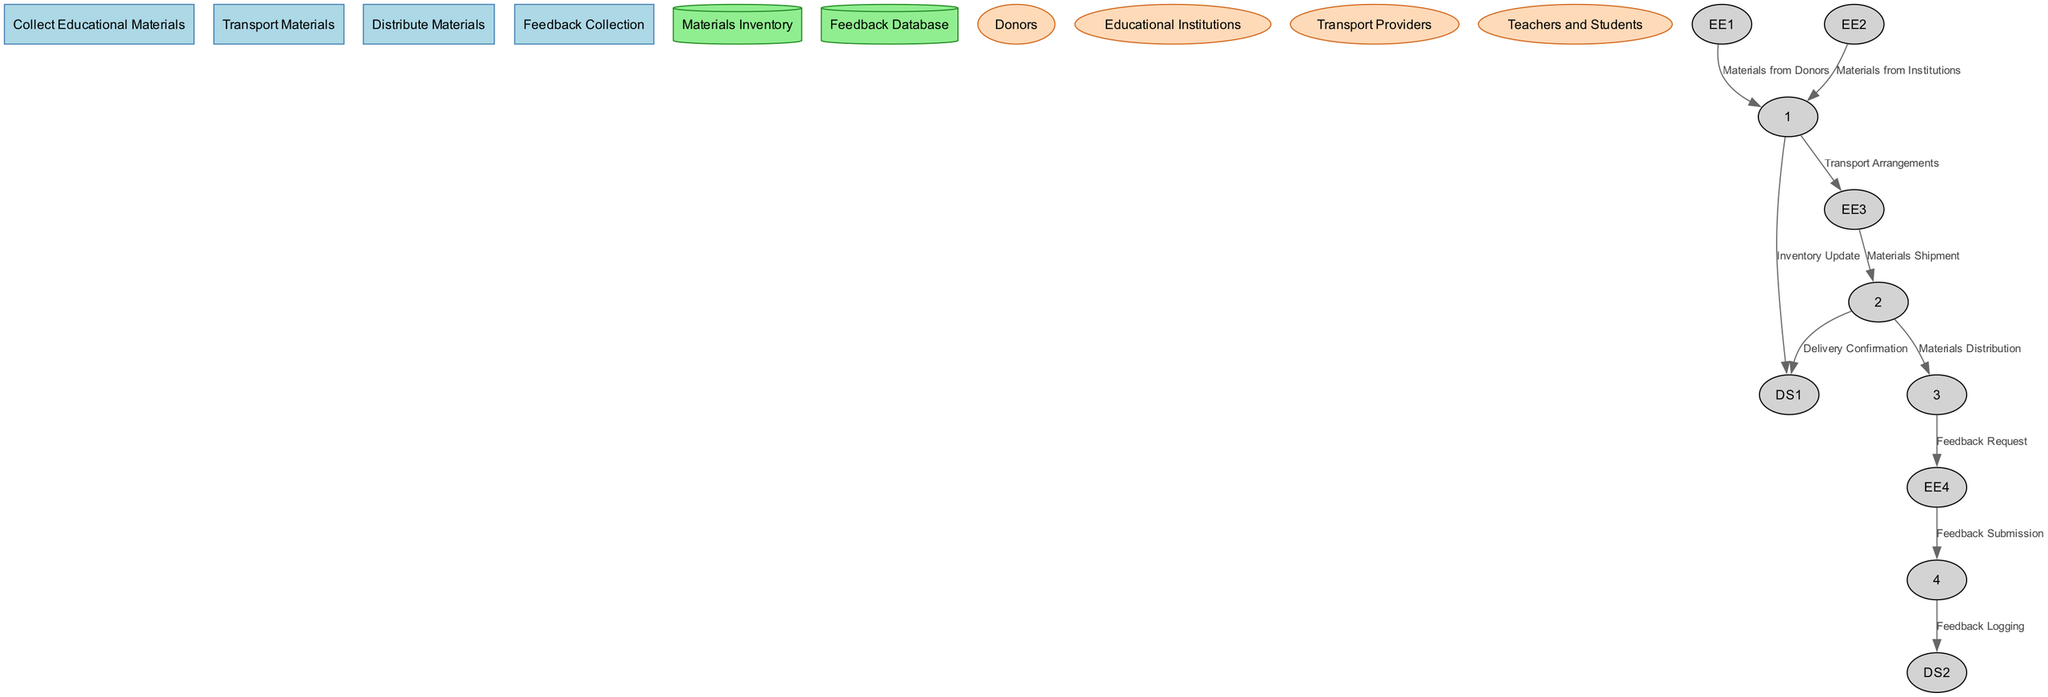What process collects educational materials? The diagram shows that the process responsible for collecting educational materials is labeled as "Collect Educational Materials." This is confirmed by the label shown in the processes section of the diagram.
Answer: Collect Educational Materials How many data stores are present in the diagram? By examining the diagram, we can see that there are two data stores listed, namely "Materials Inventory" and "Feedback Database." Therefore, counting these gives us a total of two data stores.
Answer: 2 What entity provides feedback about the materials? The entity responsible for providing feedback is "Teachers and Students," illustrated in the external entities section of the diagram. Their role is to submit feedback on the usefulness and quality of the educational materials.
Answer: Teachers and Students How many processes are there in total? The diagram includes four distinct processes: "Collect Educational Materials," "Transport Materials," "Distribute Materials," and "Feedback Collection." Counting these processes results in a total of four.
Answer: 4 What type of organization is responsible for transporting the materials? The diagram indicates that "Transport Providers" are the entities that handle the transportation of the educational materials to rural areas. This information is clearly labeled under external entities.
Answer: Transport Providers What is the purpose of the "Feedback Collection" process? The "Feedback Collection" process is meant to gather feedback from teachers and students regarding the usefulness and quality of the materials distributed. This is indicated directly in the process description within the diagram.
Answer: Collect feedback From which external entity do the materials originate? The diagram describes that educational materials originate from two external entities: "Donors" and "Educational Institutions." Collectively, they provide materials for distribution in rural areas.
Answer: Donors and Educational Institutions Which data store is updated with new inventory? The data store named "Materials Inventory" is where updates regarding newly collected materials are stored. The diagram specifically states that this inventory is updated after the collection process.
Answer: Materials Inventory What happens after the "Distribute Materials" process? After the "Distribute Materials" process, a "Feedback Request" is sent to "Teachers and Students" to gather their opinions on the distributed materials. This flow illustrates the next step following the distribution in the process cycle.
Answer: Feedback Request What kind of materials are mentioned in the diagram? The diagram references "educational materials" specifically, which include textbooks, notebooks, and educational kits. This is highlighted in the descriptions associated with each relevant process.
Answer: Educational materials 